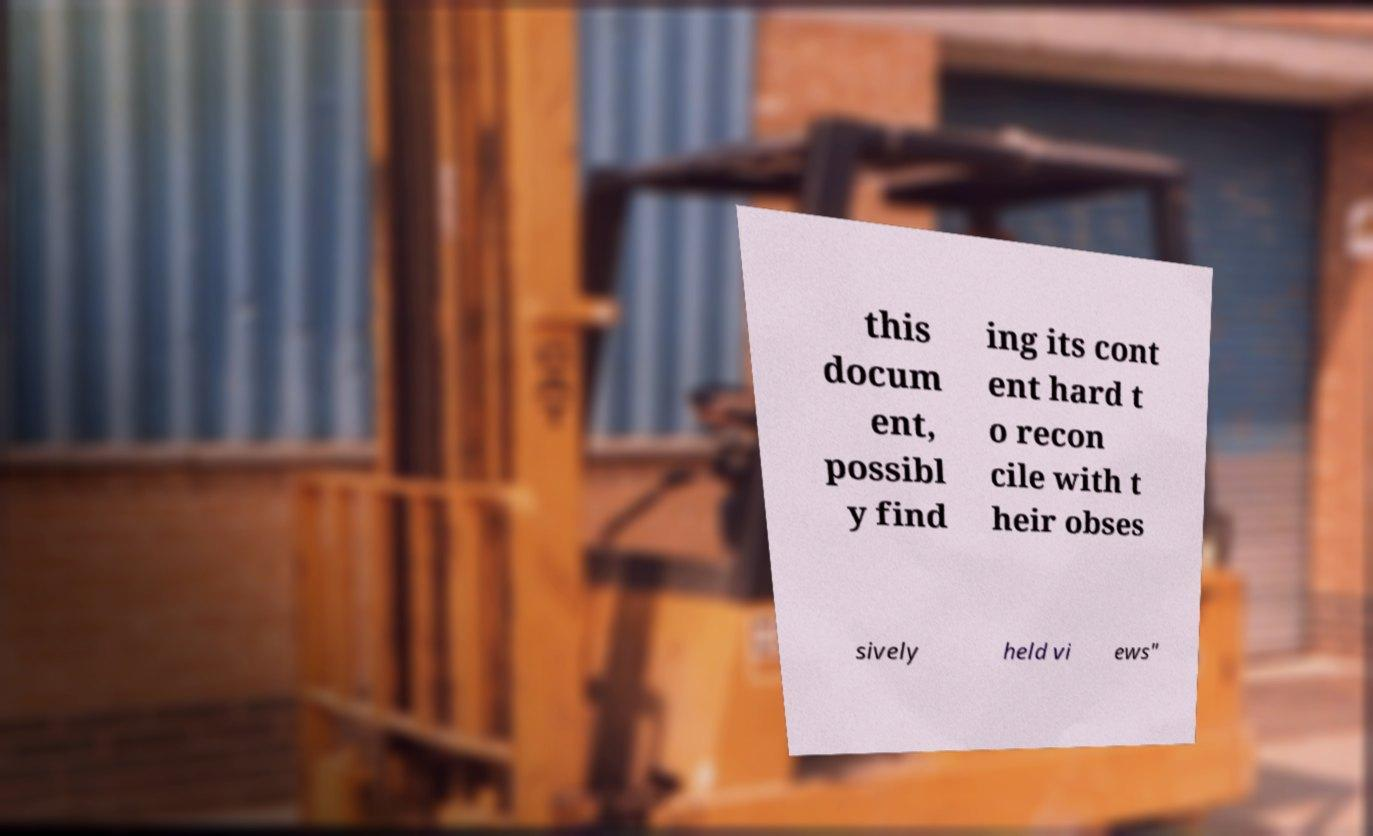Can you read and provide the text displayed in the image?This photo seems to have some interesting text. Can you extract and type it out for me? this docum ent, possibl y find ing its cont ent hard t o recon cile with t heir obses sively held vi ews" 